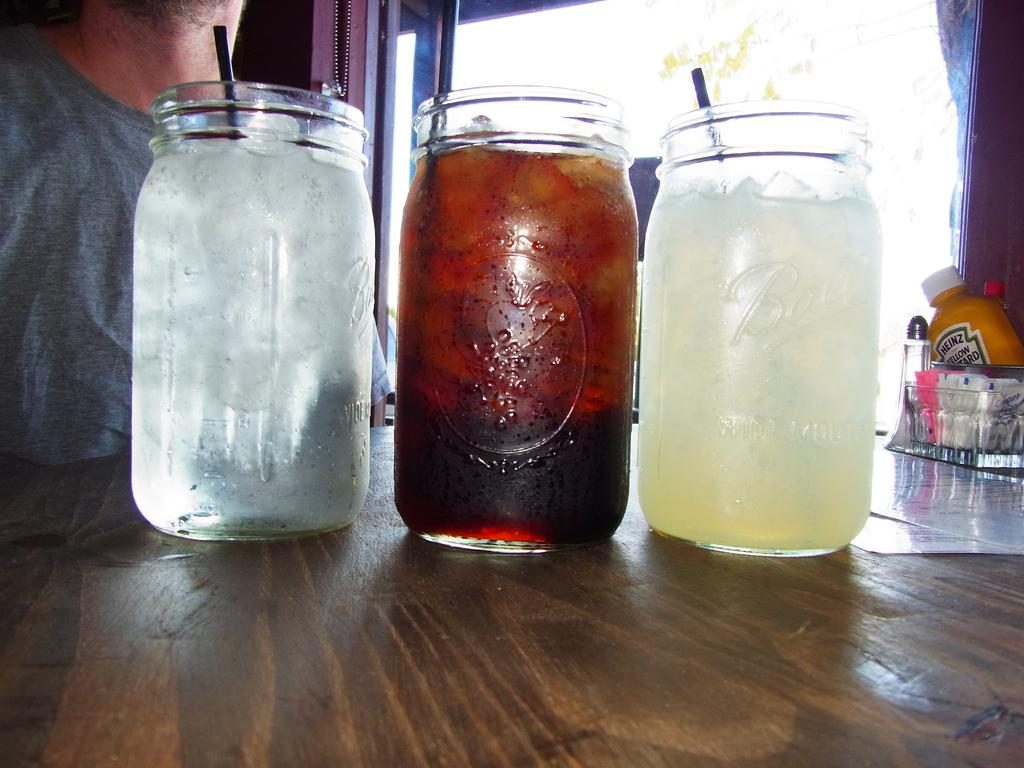How many jars are visible in the image? There are three jars in the image. What is being filled in the jars? The jars are being filled with juice. Where are the jars located? The jars are on a table. Is there anyone present near the table? Yes, there is a person standing at the left corner of the table. What type of tree can be seen growing in the prison in the image? There is no prison or tree present in the image; it features three jars being filled with juice on a table with a person standing nearby. 